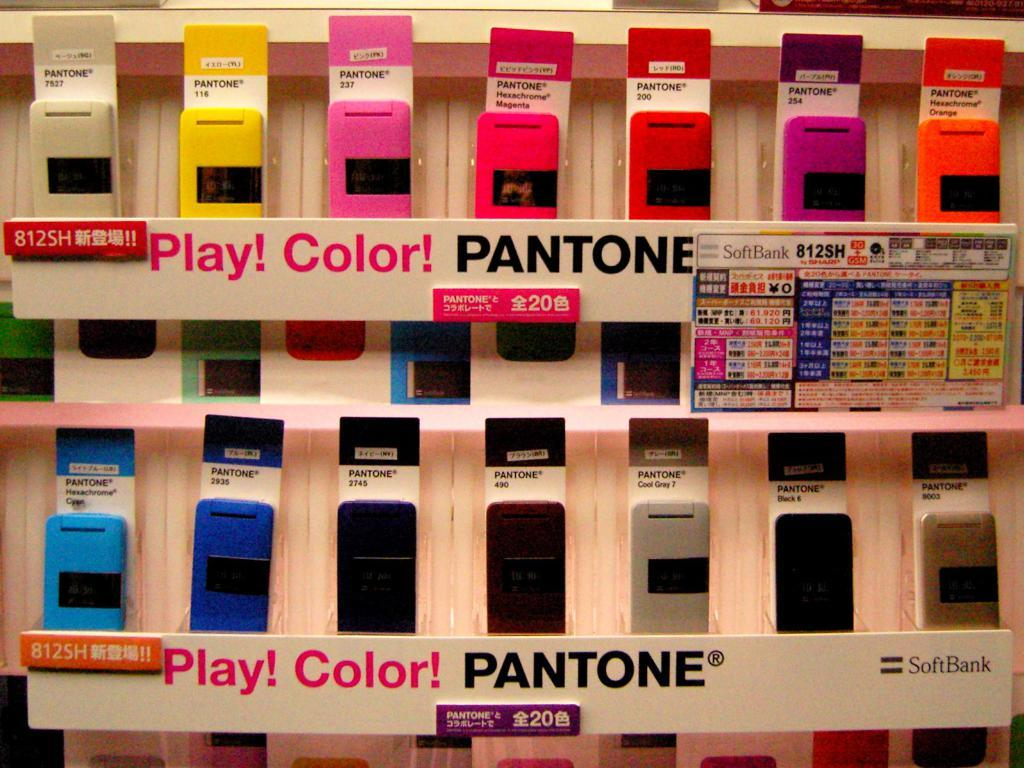<image>
Relay a brief, clear account of the picture shown. A Pantone display with many different colors that says Play! 